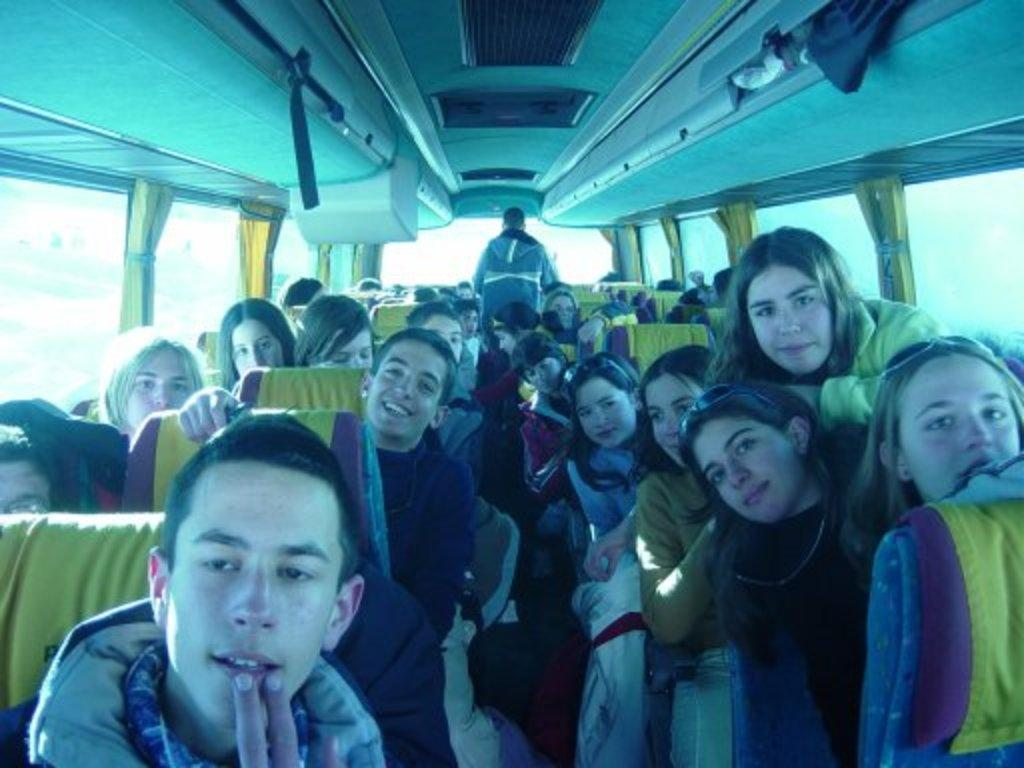What type of setting is depicted in the image? The image is an inside view of a vehicle. What are the people in the image doing? There are persons sitting on the seats, and two persons are standing. What feature is present on the sides of the vehicle? There are window glasses on the left and right sides. What is used to cover the window glasses in the image? Curtains are present near the window glasses. What type of vegetable is being used as a cover for the windows in the image? There is no vegetable present in the image; curtains are used to cover the window glasses. 